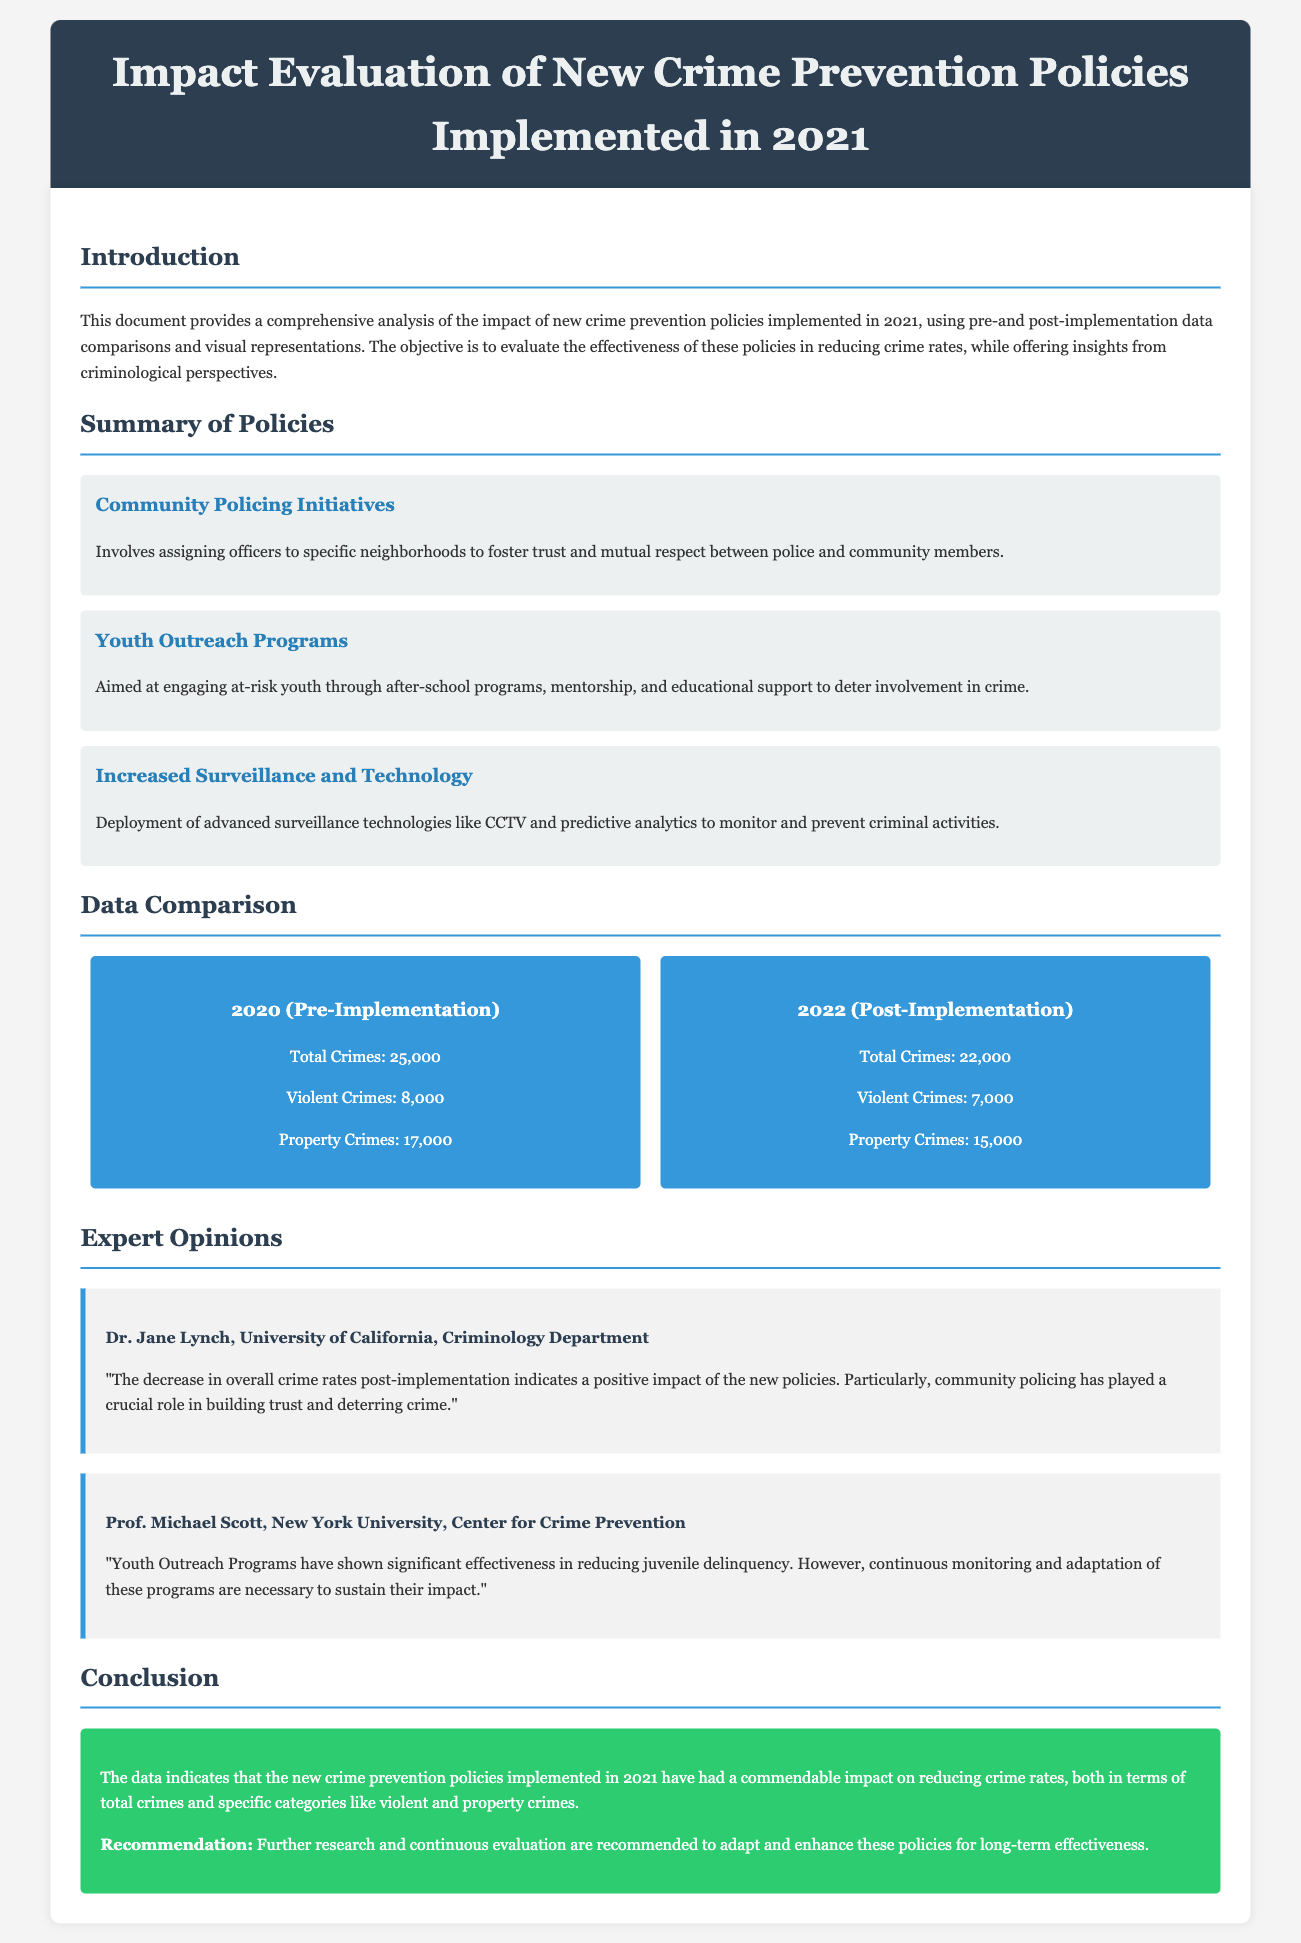What is the total number of crimes in 2020? The total number of crimes in 2020 is explicitly stated in the document.
Answer: 25,000 What are the two types of crimes listed in the data comparison? The document lists the types of crimes in the data comparison section.
Answer: Violent Crimes and Property Crimes Who is the expert quoted regarding community policing? The document provides the name of the expert discussing community policing.
Answer: Dr. Jane Lynch What year were the new crime prevention policies implemented? The implementation year of the crime prevention policies is mentioned in the introduction.
Answer: 2021 What was the total crime reduction from 2020 to 2022? The total number of crimes decreased from 25,000 in 2020 to 22,000 in 2022, allowing for calculation of the reduction.
Answer: 3,000 Which policy is aimed at at-risk youth? The summary of policies section details the aim of different policies related to youth.
Answer: Youth Outreach Programs What is the conclusion regarding the new crime prevention policies? The conclusion provides a summary of the effectiveness of the new policies in the document.
Answer: Commendable impact on reducing crime rates What is one recommendation made in the conclusion? The conclusion section lists suggestions for the future regarding crime prevention policies.
Answer: Continuous evaluation 